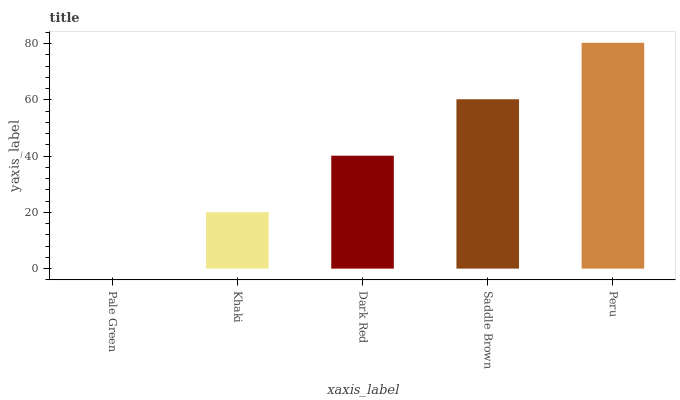Is Pale Green the minimum?
Answer yes or no. Yes. Is Peru the maximum?
Answer yes or no. Yes. Is Khaki the minimum?
Answer yes or no. No. Is Khaki the maximum?
Answer yes or no. No. Is Khaki greater than Pale Green?
Answer yes or no. Yes. Is Pale Green less than Khaki?
Answer yes or no. Yes. Is Pale Green greater than Khaki?
Answer yes or no. No. Is Khaki less than Pale Green?
Answer yes or no. No. Is Dark Red the high median?
Answer yes or no. Yes. Is Dark Red the low median?
Answer yes or no. Yes. Is Pale Green the high median?
Answer yes or no. No. Is Peru the low median?
Answer yes or no. No. 